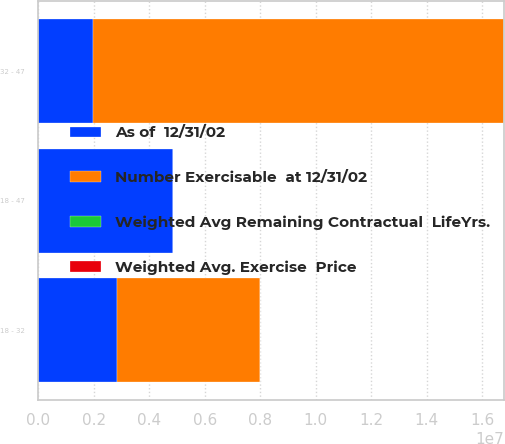Convert chart to OTSL. <chart><loc_0><loc_0><loc_500><loc_500><stacked_bar_chart><ecel><fcel>18 - 32<fcel>32 - 47<fcel>18 - 47<nl><fcel>Number Exercisable  at 12/31/02<fcel>5.14484e+06<fcel>1.47983e+07<fcel>39.52<nl><fcel>Weighted Avg Remaining Contractual  LifeYrs.<fcel>7.2<fcel>8.6<fcel>8.2<nl><fcel>Weighted Avg. Exercise  Price<fcel>25.28<fcel>39.52<fcel>35.85<nl><fcel>As of  12/31/02<fcel>2.85058e+06<fcel>1.98694e+06<fcel>4.83751e+06<nl></chart> 